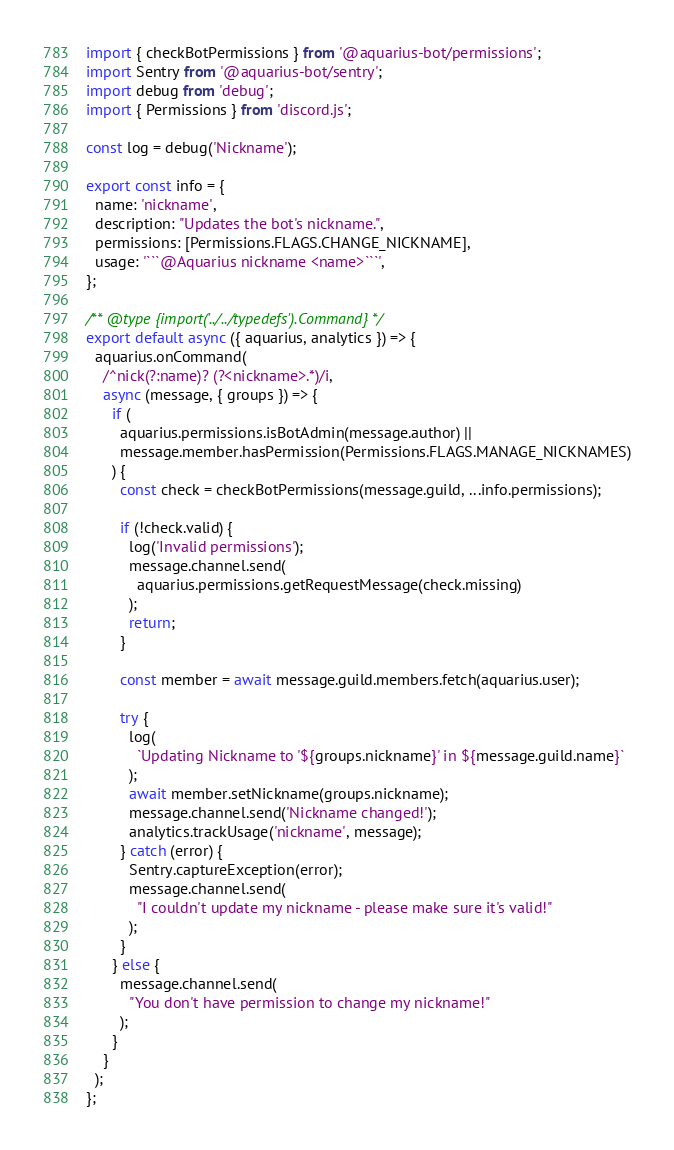<code> <loc_0><loc_0><loc_500><loc_500><_JavaScript_>import { checkBotPermissions } from '@aquarius-bot/permissions';
import Sentry from '@aquarius-bot/sentry';
import debug from 'debug';
import { Permissions } from 'discord.js';

const log = debug('Nickname');

export const info = {
  name: 'nickname',
  description: "Updates the bot's nickname.",
  permissions: [Permissions.FLAGS.CHANGE_NICKNAME],
  usage: '```@Aquarius nickname <name>```',
};

/** @type {import('../../typedefs').Command} */
export default async ({ aquarius, analytics }) => {
  aquarius.onCommand(
    /^nick(?:name)? (?<nickname>.*)/i,
    async (message, { groups }) => {
      if (
        aquarius.permissions.isBotAdmin(message.author) ||
        message.member.hasPermission(Permissions.FLAGS.MANAGE_NICKNAMES)
      ) {
        const check = checkBotPermissions(message.guild, ...info.permissions);

        if (!check.valid) {
          log('Invalid permissions');
          message.channel.send(
            aquarius.permissions.getRequestMessage(check.missing)
          );
          return;
        }

        const member = await message.guild.members.fetch(aquarius.user);

        try {
          log(
            `Updating Nickname to '${groups.nickname}' in ${message.guild.name}`
          );
          await member.setNickname(groups.nickname);
          message.channel.send('Nickname changed!');
          analytics.trackUsage('nickname', message);
        } catch (error) {
          Sentry.captureException(error);
          message.channel.send(
            "I couldn't update my nickname - please make sure it's valid!"
          );
        }
      } else {
        message.channel.send(
          "You don't have permission to change my nickname!"
        );
      }
    }
  );
};
</code> 